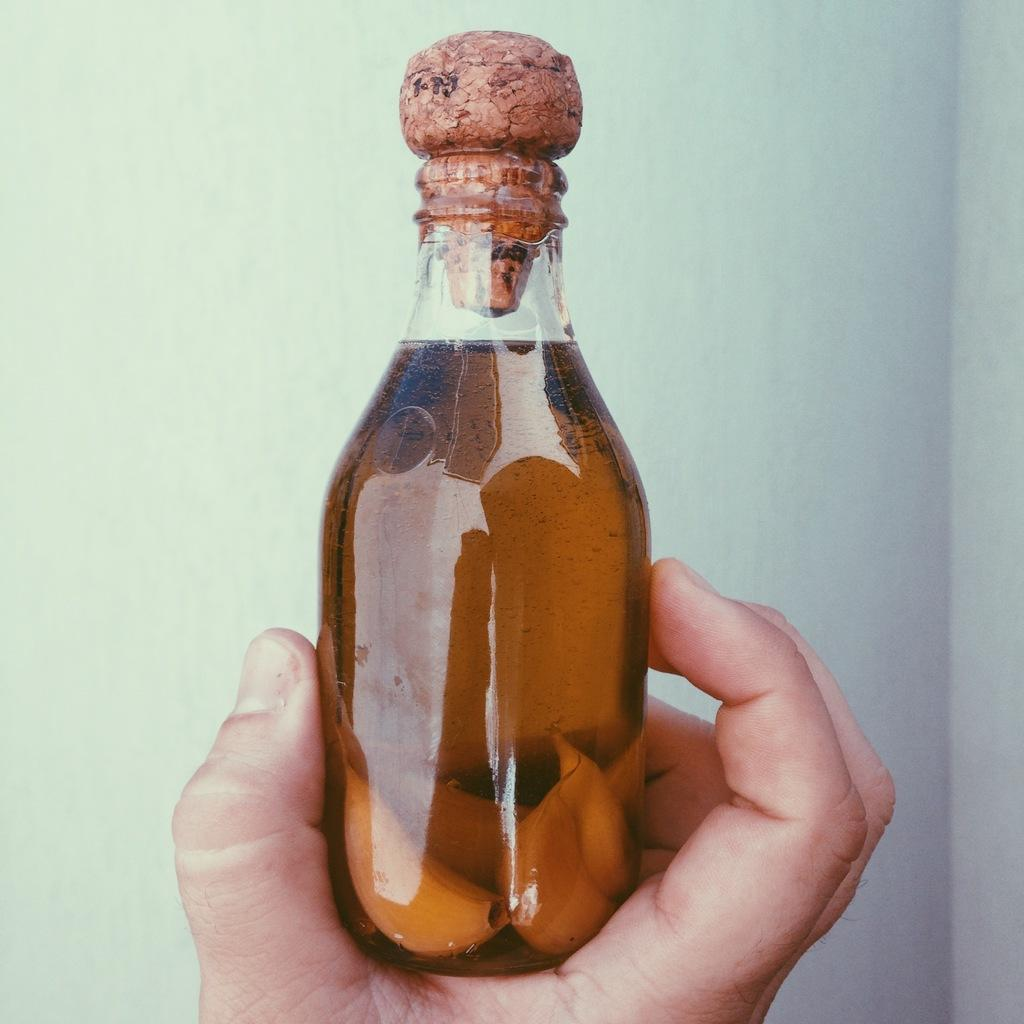What is the person holding in the image? The person is holding a bottle in the image. What is inside the bottle? The bottle contains liquid with garlic pieces in it. How is the bottle sealed? The bottle is closed with a lid. What type of bells can be heard ringing in the image? There are no bells present in the image, and therefore no sound can be heard. 